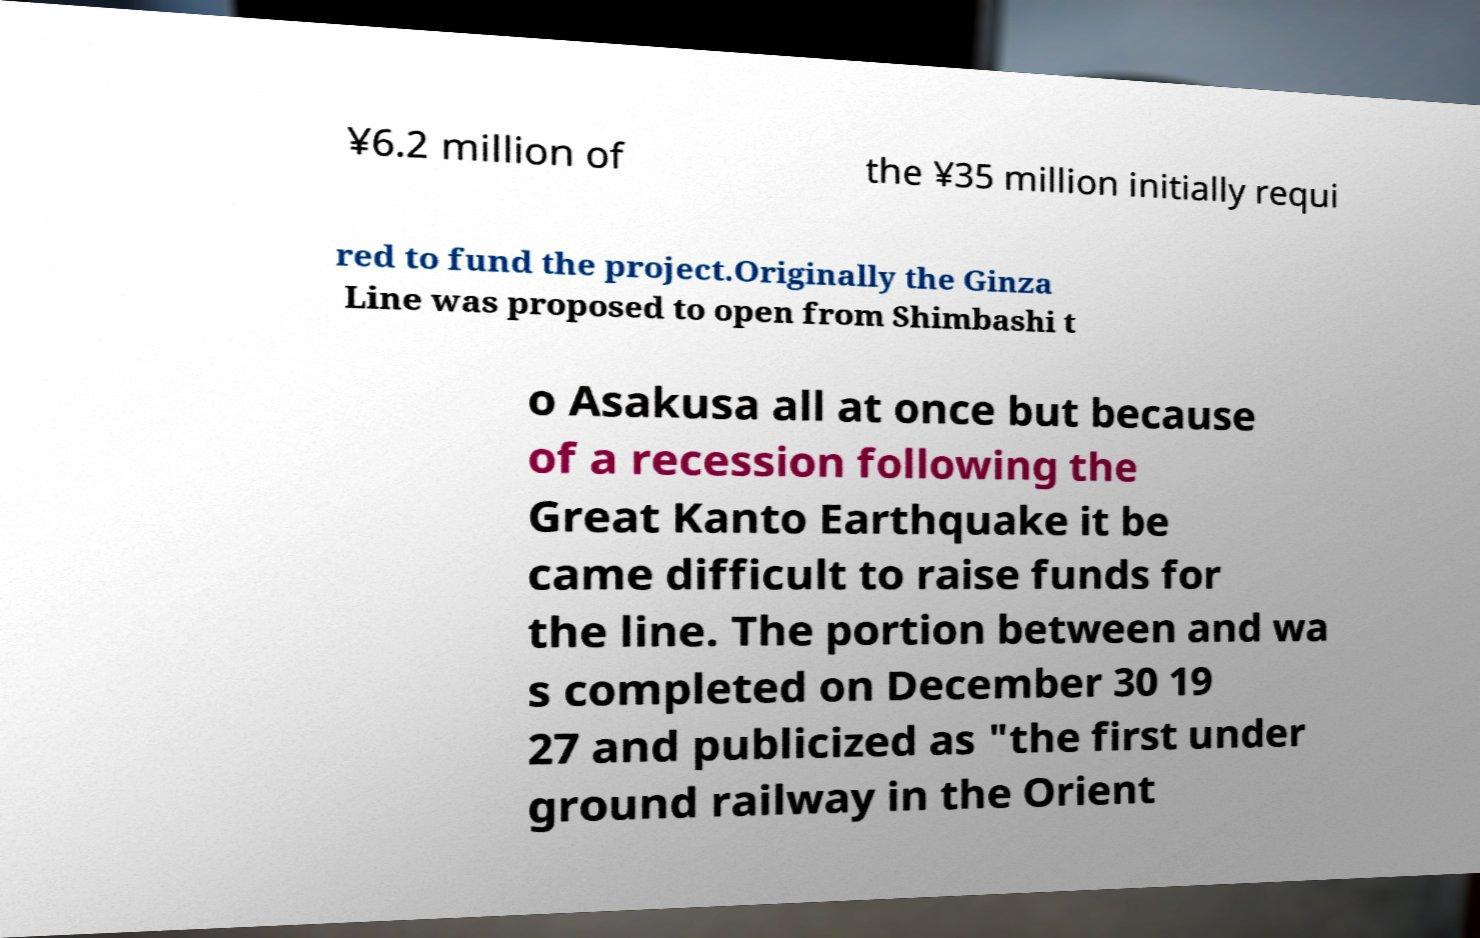What messages or text are displayed in this image? I need them in a readable, typed format. ¥6.2 million of the ¥35 million initially requi red to fund the project.Originally the Ginza Line was proposed to open from Shimbashi t o Asakusa all at once but because of a recession following the Great Kanto Earthquake it be came difficult to raise funds for the line. The portion between and wa s completed on December 30 19 27 and publicized as "the first under ground railway in the Orient 